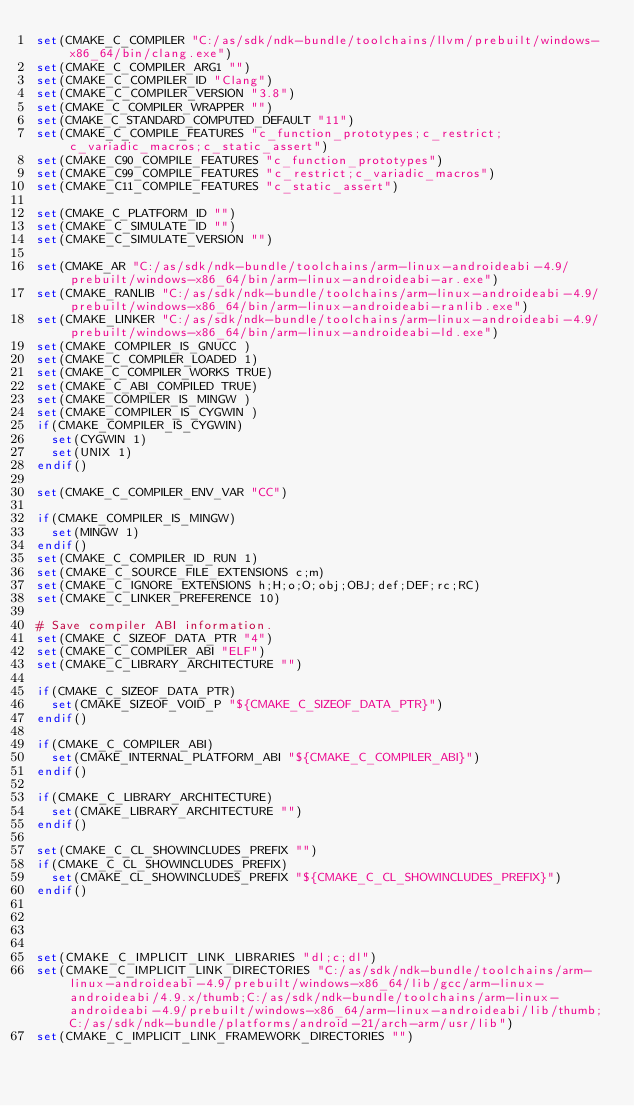<code> <loc_0><loc_0><loc_500><loc_500><_CMake_>set(CMAKE_C_COMPILER "C:/as/sdk/ndk-bundle/toolchains/llvm/prebuilt/windows-x86_64/bin/clang.exe")
set(CMAKE_C_COMPILER_ARG1 "")
set(CMAKE_C_COMPILER_ID "Clang")
set(CMAKE_C_COMPILER_VERSION "3.8")
set(CMAKE_C_COMPILER_WRAPPER "")
set(CMAKE_C_STANDARD_COMPUTED_DEFAULT "11")
set(CMAKE_C_COMPILE_FEATURES "c_function_prototypes;c_restrict;c_variadic_macros;c_static_assert")
set(CMAKE_C90_COMPILE_FEATURES "c_function_prototypes")
set(CMAKE_C99_COMPILE_FEATURES "c_restrict;c_variadic_macros")
set(CMAKE_C11_COMPILE_FEATURES "c_static_assert")

set(CMAKE_C_PLATFORM_ID "")
set(CMAKE_C_SIMULATE_ID "")
set(CMAKE_C_SIMULATE_VERSION "")

set(CMAKE_AR "C:/as/sdk/ndk-bundle/toolchains/arm-linux-androideabi-4.9/prebuilt/windows-x86_64/bin/arm-linux-androideabi-ar.exe")
set(CMAKE_RANLIB "C:/as/sdk/ndk-bundle/toolchains/arm-linux-androideabi-4.9/prebuilt/windows-x86_64/bin/arm-linux-androideabi-ranlib.exe")
set(CMAKE_LINKER "C:/as/sdk/ndk-bundle/toolchains/arm-linux-androideabi-4.9/prebuilt/windows-x86_64/bin/arm-linux-androideabi-ld.exe")
set(CMAKE_COMPILER_IS_GNUCC )
set(CMAKE_C_COMPILER_LOADED 1)
set(CMAKE_C_COMPILER_WORKS TRUE)
set(CMAKE_C_ABI_COMPILED TRUE)
set(CMAKE_COMPILER_IS_MINGW )
set(CMAKE_COMPILER_IS_CYGWIN )
if(CMAKE_COMPILER_IS_CYGWIN)
  set(CYGWIN 1)
  set(UNIX 1)
endif()

set(CMAKE_C_COMPILER_ENV_VAR "CC")

if(CMAKE_COMPILER_IS_MINGW)
  set(MINGW 1)
endif()
set(CMAKE_C_COMPILER_ID_RUN 1)
set(CMAKE_C_SOURCE_FILE_EXTENSIONS c;m)
set(CMAKE_C_IGNORE_EXTENSIONS h;H;o;O;obj;OBJ;def;DEF;rc;RC)
set(CMAKE_C_LINKER_PREFERENCE 10)

# Save compiler ABI information.
set(CMAKE_C_SIZEOF_DATA_PTR "4")
set(CMAKE_C_COMPILER_ABI "ELF")
set(CMAKE_C_LIBRARY_ARCHITECTURE "")

if(CMAKE_C_SIZEOF_DATA_PTR)
  set(CMAKE_SIZEOF_VOID_P "${CMAKE_C_SIZEOF_DATA_PTR}")
endif()

if(CMAKE_C_COMPILER_ABI)
  set(CMAKE_INTERNAL_PLATFORM_ABI "${CMAKE_C_COMPILER_ABI}")
endif()

if(CMAKE_C_LIBRARY_ARCHITECTURE)
  set(CMAKE_LIBRARY_ARCHITECTURE "")
endif()

set(CMAKE_C_CL_SHOWINCLUDES_PREFIX "")
if(CMAKE_C_CL_SHOWINCLUDES_PREFIX)
  set(CMAKE_CL_SHOWINCLUDES_PREFIX "${CMAKE_C_CL_SHOWINCLUDES_PREFIX}")
endif()




set(CMAKE_C_IMPLICIT_LINK_LIBRARIES "dl;c;dl")
set(CMAKE_C_IMPLICIT_LINK_DIRECTORIES "C:/as/sdk/ndk-bundle/toolchains/arm-linux-androideabi-4.9/prebuilt/windows-x86_64/lib/gcc/arm-linux-androideabi/4.9.x/thumb;C:/as/sdk/ndk-bundle/toolchains/arm-linux-androideabi-4.9/prebuilt/windows-x86_64/arm-linux-androideabi/lib/thumb;C:/as/sdk/ndk-bundle/platforms/android-21/arch-arm/usr/lib")
set(CMAKE_C_IMPLICIT_LINK_FRAMEWORK_DIRECTORIES "")
</code> 